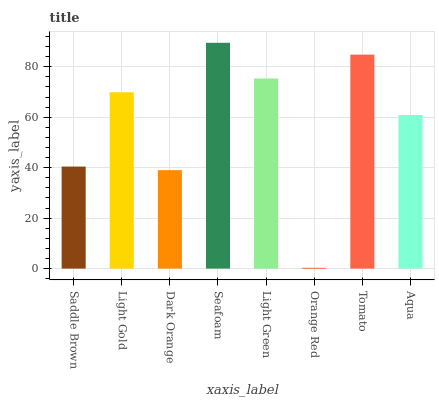Is Light Gold the minimum?
Answer yes or no. No. Is Light Gold the maximum?
Answer yes or no. No. Is Light Gold greater than Saddle Brown?
Answer yes or no. Yes. Is Saddle Brown less than Light Gold?
Answer yes or no. Yes. Is Saddle Brown greater than Light Gold?
Answer yes or no. No. Is Light Gold less than Saddle Brown?
Answer yes or no. No. Is Light Gold the high median?
Answer yes or no. Yes. Is Aqua the low median?
Answer yes or no. Yes. Is Orange Red the high median?
Answer yes or no. No. Is Saddle Brown the low median?
Answer yes or no. No. 